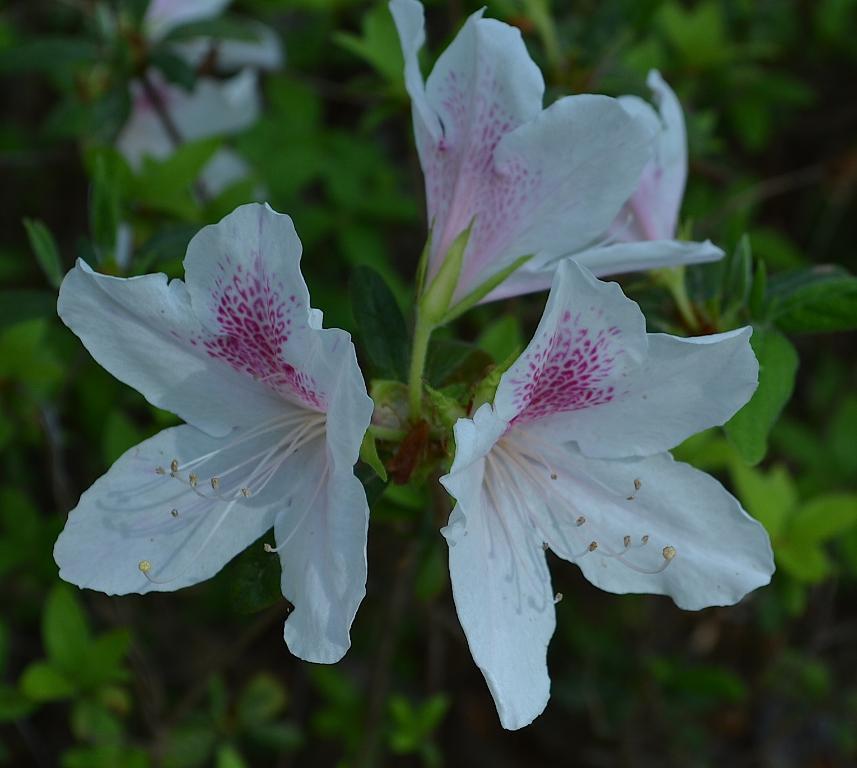Please provide a concise description of this image. In this image I can see flowers in white and pink color and leaves in green color. 